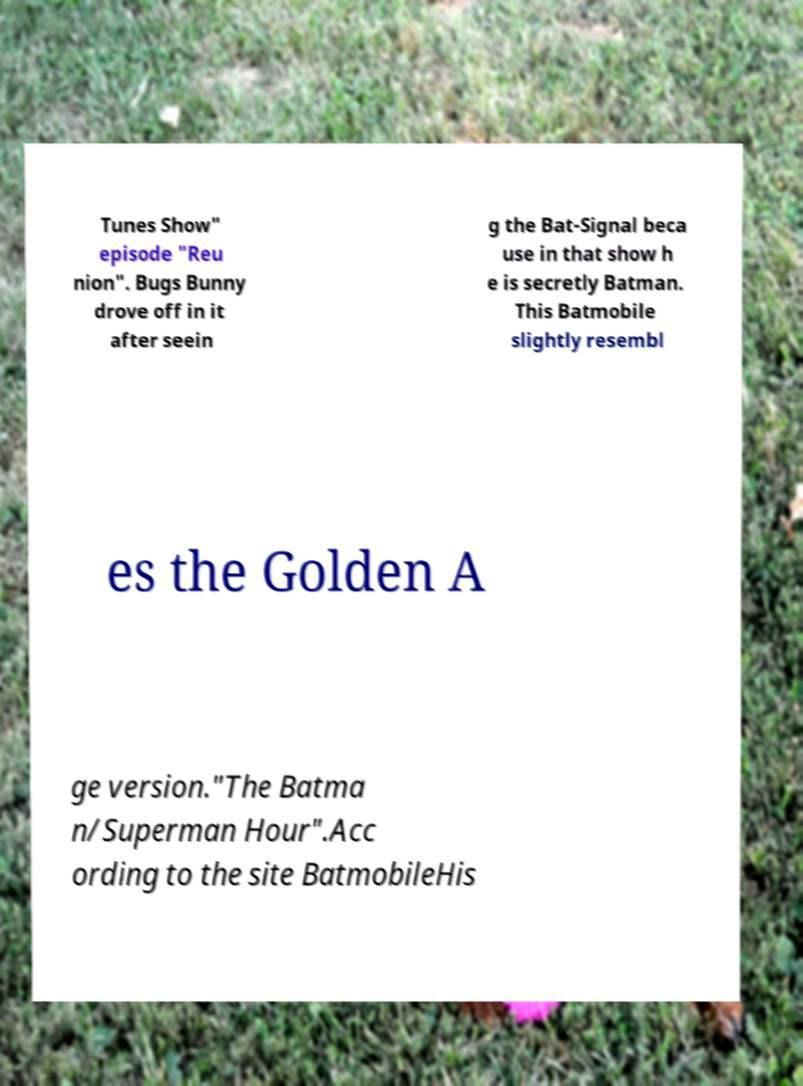Can you accurately transcribe the text from the provided image for me? Tunes Show" episode "Reu nion". Bugs Bunny drove off in it after seein g the Bat-Signal beca use in that show h e is secretly Batman. This Batmobile slightly resembl es the Golden A ge version."The Batma n/Superman Hour".Acc ording to the site BatmobileHis 